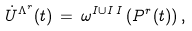Convert formula to latex. <formula><loc_0><loc_0><loc_500><loc_500>\dot { U } ^ { \Lambda ^ { r } } ( t ) \, = \, \omega ^ { I \cup I \, I } \left ( P ^ { r } ( t ) \right ) ,</formula> 